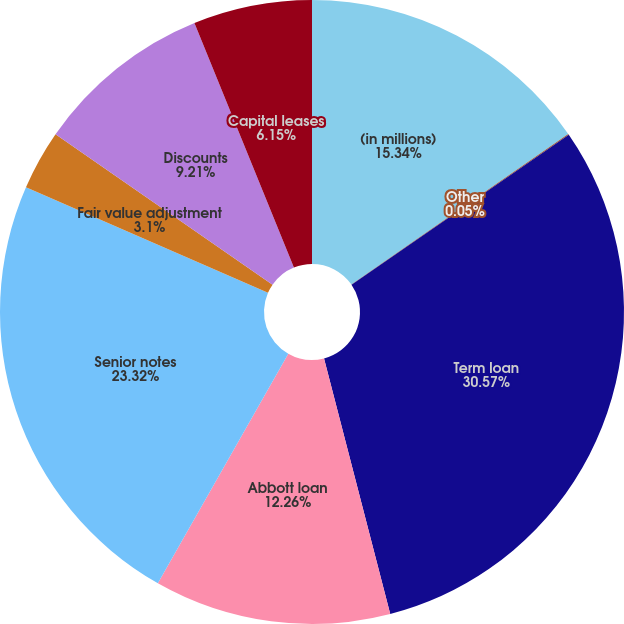<chart> <loc_0><loc_0><loc_500><loc_500><pie_chart><fcel>(in millions)<fcel>Other<fcel>Term loan<fcel>Abbott loan<fcel>Senior notes<fcel>Fair value adjustment<fcel>Discounts<fcel>Capital leases<nl><fcel>15.34%<fcel>0.05%<fcel>30.58%<fcel>12.26%<fcel>23.32%<fcel>3.1%<fcel>9.21%<fcel>6.15%<nl></chart> 